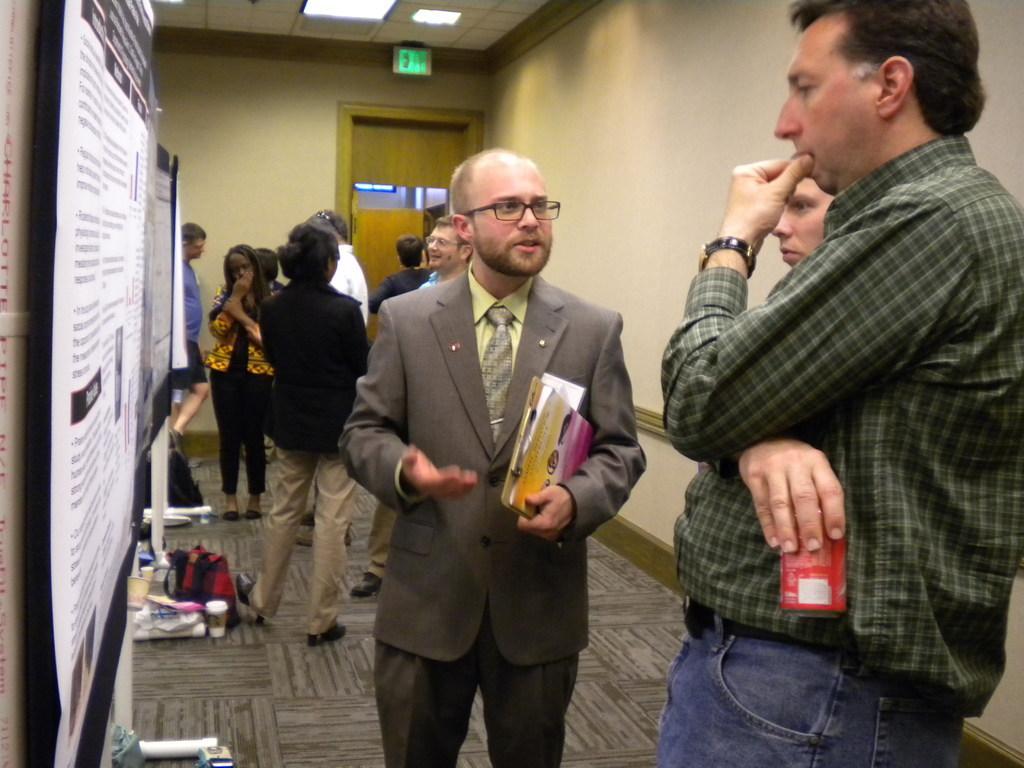Please provide a concise description of this image. In this image I can see a person wearing green shirt and blue jeans and another person wearing grey colored dress are standing and holding few objects in their hands. To the left side of the image I can see a banner attached to the wall. In the background I can see few persons standing, the wall, the door, the ceiling, few lights to the ceiling and few objects on the floor. 